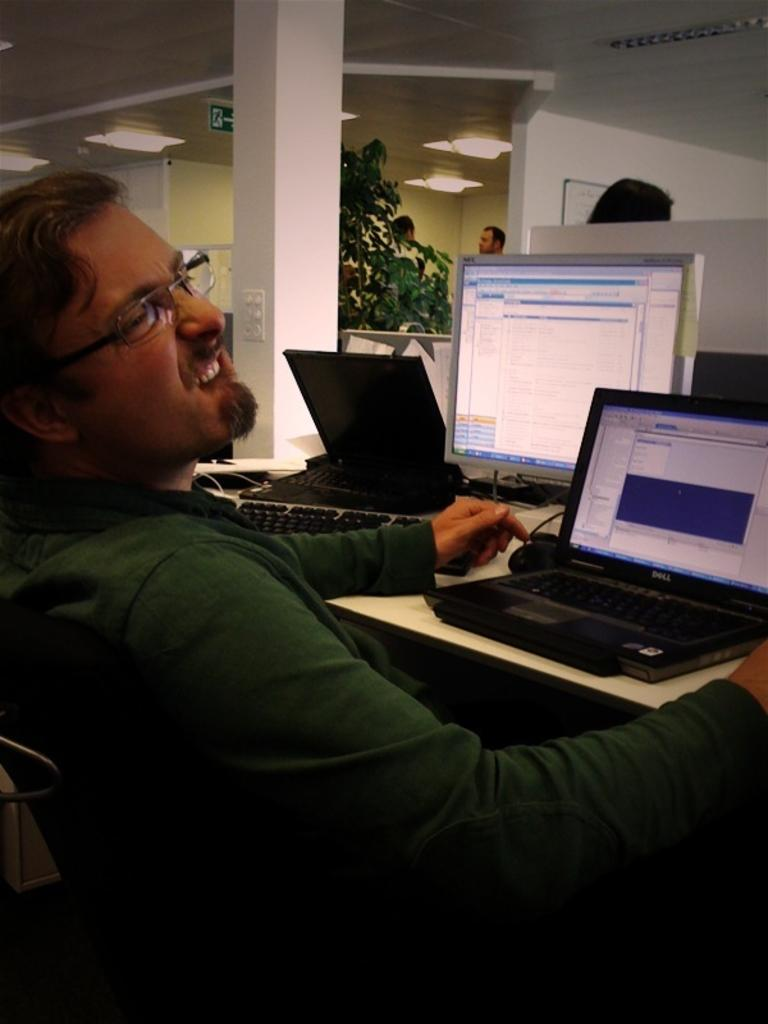Who is present in the image? There is a man in the image. What is the man doing in the image? The man is sitting on a chair. What is in front of the man? There is a table in front of the man. What electronic devices are on the table? There are two laptops and a monitor on the table. What can be seen in the background of the image? There is a tree visible in the background. What type of treatment is the man receiving in the image? There is no indication in the image that the man is receiving any treatment. 